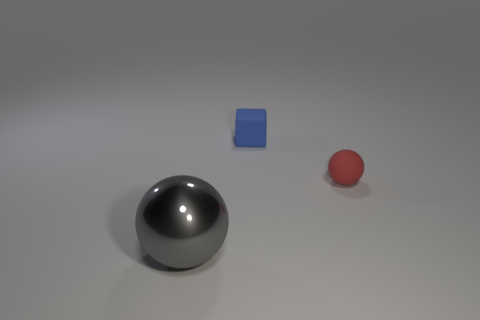Add 2 blue rubber cubes. How many objects exist? 5 Subtract all spheres. How many objects are left? 1 Subtract 0 blue balls. How many objects are left? 3 Subtract all tiny green metallic blocks. Subtract all gray objects. How many objects are left? 2 Add 2 small red things. How many small red things are left? 3 Add 3 metal things. How many metal things exist? 4 